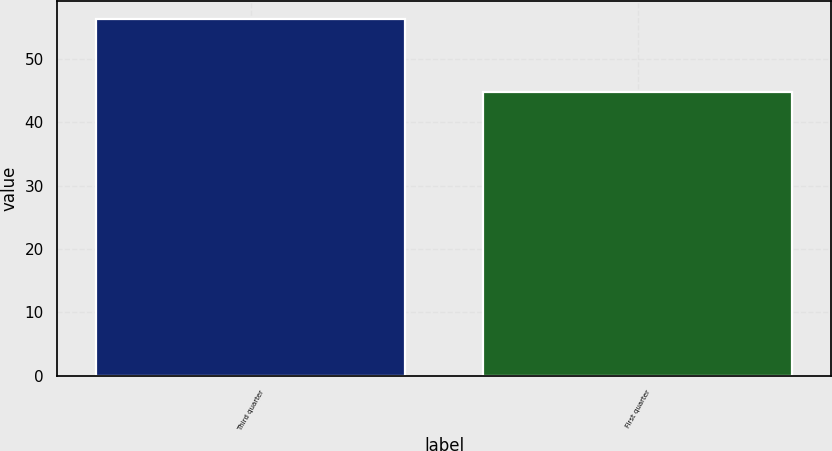Convert chart to OTSL. <chart><loc_0><loc_0><loc_500><loc_500><bar_chart><fcel>Third quarter<fcel>First quarter<nl><fcel>56.35<fcel>44.82<nl></chart> 